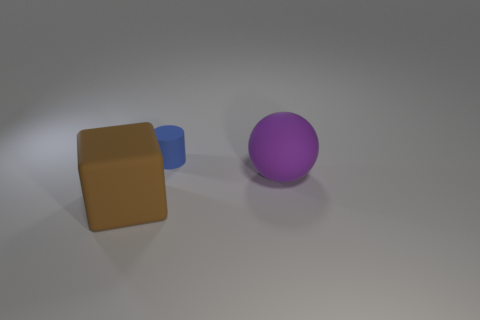What number of shiny things are either large blocks or big brown spheres? In the image, there are a total of two shiny objects; one is a large brown block, and the other is a purple sphere which does not meet the condition of being big and brown. There are no big brown spheres present, so the number of objects that are either large blocks or big brown spheres is one. 